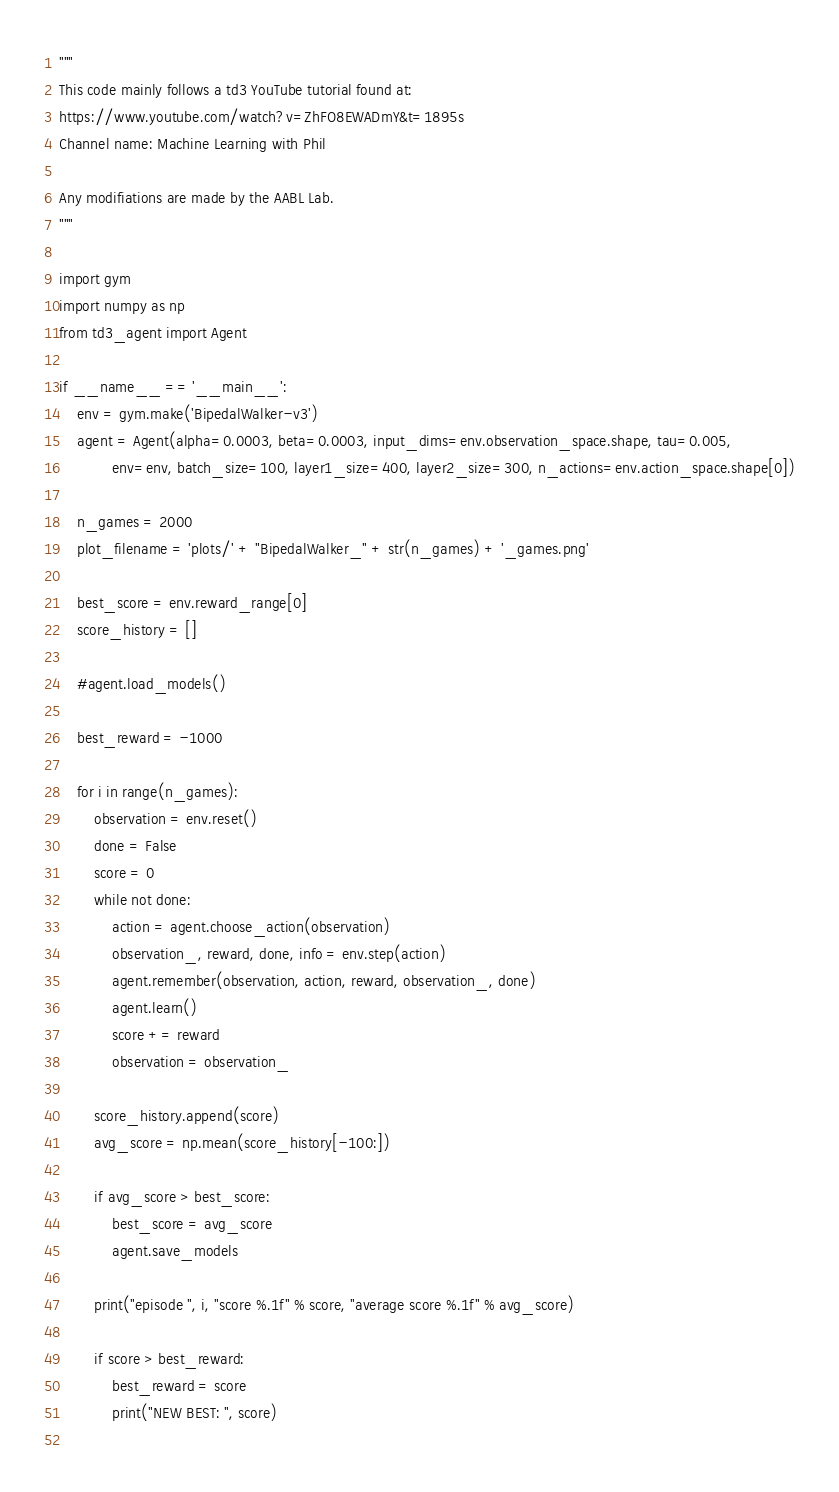Convert code to text. <code><loc_0><loc_0><loc_500><loc_500><_Python_>"""
This code mainly follows a td3 YouTube tutorial found at:
https://www.youtube.com/watch?v=ZhFO8EWADmY&t=1895s
Channel name: Machine Learning with Phil

Any modifiations are made by the AABL Lab.
"""

import gym
import numpy as np
from td3_agent import Agent

if __name__ == '__main__':
    env = gym.make('BipedalWalker-v3')
    agent = Agent(alpha=0.0003, beta=0.0003, input_dims=env.observation_space.shape, tau=0.005,
            env=env, batch_size=100, layer1_size=400, layer2_size=300, n_actions=env.action_space.shape[0])
    
    n_games = 2000
    plot_filename = 'plots/' + "BipedalWalker_" + str(n_games) + '_games.png'

    best_score = env.reward_range[0]
    score_history = []

    #agent.load_models()

    best_reward = -1000

    for i in range(n_games):
        observation = env.reset()
        done = False
        score = 0
        while not done:
            action = agent.choose_action(observation)
            observation_, reward, done, info = env.step(action)
            agent.remember(observation, action, reward, observation_, done)
            agent.learn()
            score += reward
            observation = observation_

        score_history.append(score)
        avg_score = np.mean(score_history[-100:])

        if avg_score > best_score:
            best_score = avg_score
            agent.save_models
        
        print("episode ", i, "score %.1f" % score, "average score %.1f" % avg_score)

        if score > best_reward:
            best_reward = score
            print("NEW BEST: ", score)
        </code> 